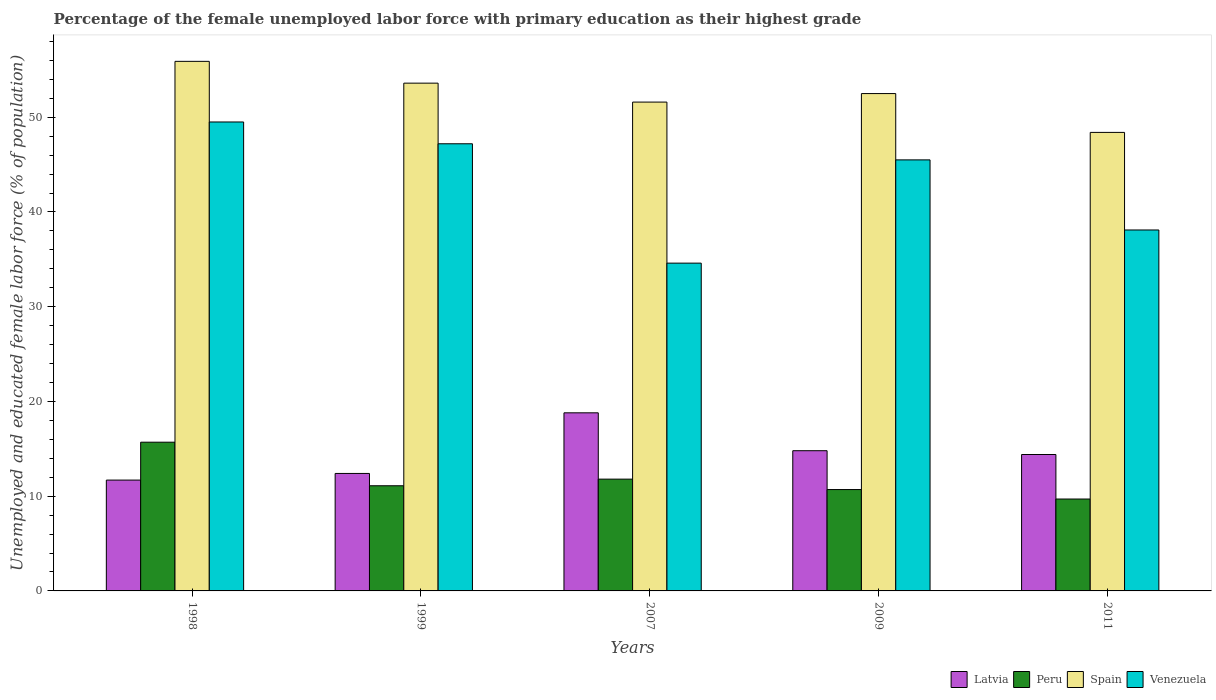How many different coloured bars are there?
Your response must be concise. 4. Are the number of bars per tick equal to the number of legend labels?
Provide a short and direct response. Yes. How many bars are there on the 2nd tick from the right?
Offer a very short reply. 4. What is the label of the 3rd group of bars from the left?
Ensure brevity in your answer.  2007. What is the percentage of the unemployed female labor force with primary education in Spain in 2007?
Make the answer very short. 51.6. Across all years, what is the maximum percentage of the unemployed female labor force with primary education in Latvia?
Make the answer very short. 18.8. Across all years, what is the minimum percentage of the unemployed female labor force with primary education in Peru?
Provide a short and direct response. 9.7. In which year was the percentage of the unemployed female labor force with primary education in Latvia minimum?
Make the answer very short. 1998. What is the total percentage of the unemployed female labor force with primary education in Venezuela in the graph?
Keep it short and to the point. 214.9. What is the difference between the percentage of the unemployed female labor force with primary education in Latvia in 1998 and that in 2007?
Provide a succinct answer. -7.1. What is the difference between the percentage of the unemployed female labor force with primary education in Venezuela in 2007 and the percentage of the unemployed female labor force with primary education in Latvia in 1998?
Your answer should be very brief. 22.9. What is the average percentage of the unemployed female labor force with primary education in Venezuela per year?
Keep it short and to the point. 42.98. In the year 2007, what is the difference between the percentage of the unemployed female labor force with primary education in Peru and percentage of the unemployed female labor force with primary education in Latvia?
Keep it short and to the point. -7. What is the ratio of the percentage of the unemployed female labor force with primary education in Venezuela in 1999 to that in 2011?
Your response must be concise. 1.24. Is the percentage of the unemployed female labor force with primary education in Venezuela in 2009 less than that in 2011?
Provide a short and direct response. No. What is the difference between the highest and the second highest percentage of the unemployed female labor force with primary education in Venezuela?
Provide a short and direct response. 2.3. What is the difference between the highest and the lowest percentage of the unemployed female labor force with primary education in Latvia?
Keep it short and to the point. 7.1. In how many years, is the percentage of the unemployed female labor force with primary education in Spain greater than the average percentage of the unemployed female labor force with primary education in Spain taken over all years?
Your answer should be compact. 3. Is the sum of the percentage of the unemployed female labor force with primary education in Latvia in 1998 and 2009 greater than the maximum percentage of the unemployed female labor force with primary education in Peru across all years?
Give a very brief answer. Yes. What does the 4th bar from the left in 2007 represents?
Offer a terse response. Venezuela. What does the 1st bar from the right in 2007 represents?
Ensure brevity in your answer.  Venezuela. Is it the case that in every year, the sum of the percentage of the unemployed female labor force with primary education in Spain and percentage of the unemployed female labor force with primary education in Latvia is greater than the percentage of the unemployed female labor force with primary education in Venezuela?
Make the answer very short. Yes. How many bars are there?
Provide a short and direct response. 20. How many years are there in the graph?
Keep it short and to the point. 5. What is the difference between two consecutive major ticks on the Y-axis?
Offer a very short reply. 10. Does the graph contain any zero values?
Offer a very short reply. No. Does the graph contain grids?
Ensure brevity in your answer.  No. Where does the legend appear in the graph?
Your response must be concise. Bottom right. How many legend labels are there?
Provide a succinct answer. 4. How are the legend labels stacked?
Keep it short and to the point. Horizontal. What is the title of the graph?
Keep it short and to the point. Percentage of the female unemployed labor force with primary education as their highest grade. What is the label or title of the X-axis?
Give a very brief answer. Years. What is the label or title of the Y-axis?
Your response must be concise. Unemployed and educated female labor force (% of population). What is the Unemployed and educated female labor force (% of population) in Latvia in 1998?
Your response must be concise. 11.7. What is the Unemployed and educated female labor force (% of population) in Peru in 1998?
Make the answer very short. 15.7. What is the Unemployed and educated female labor force (% of population) in Spain in 1998?
Ensure brevity in your answer.  55.9. What is the Unemployed and educated female labor force (% of population) in Venezuela in 1998?
Offer a terse response. 49.5. What is the Unemployed and educated female labor force (% of population) of Latvia in 1999?
Your answer should be very brief. 12.4. What is the Unemployed and educated female labor force (% of population) in Peru in 1999?
Keep it short and to the point. 11.1. What is the Unemployed and educated female labor force (% of population) in Spain in 1999?
Your response must be concise. 53.6. What is the Unemployed and educated female labor force (% of population) in Venezuela in 1999?
Provide a succinct answer. 47.2. What is the Unemployed and educated female labor force (% of population) in Latvia in 2007?
Keep it short and to the point. 18.8. What is the Unemployed and educated female labor force (% of population) in Peru in 2007?
Give a very brief answer. 11.8. What is the Unemployed and educated female labor force (% of population) of Spain in 2007?
Give a very brief answer. 51.6. What is the Unemployed and educated female labor force (% of population) of Venezuela in 2007?
Offer a terse response. 34.6. What is the Unemployed and educated female labor force (% of population) in Latvia in 2009?
Keep it short and to the point. 14.8. What is the Unemployed and educated female labor force (% of population) in Peru in 2009?
Provide a short and direct response. 10.7. What is the Unemployed and educated female labor force (% of population) of Spain in 2009?
Give a very brief answer. 52.5. What is the Unemployed and educated female labor force (% of population) in Venezuela in 2009?
Keep it short and to the point. 45.5. What is the Unemployed and educated female labor force (% of population) in Latvia in 2011?
Offer a terse response. 14.4. What is the Unemployed and educated female labor force (% of population) in Peru in 2011?
Your answer should be very brief. 9.7. What is the Unemployed and educated female labor force (% of population) of Spain in 2011?
Offer a terse response. 48.4. What is the Unemployed and educated female labor force (% of population) of Venezuela in 2011?
Provide a short and direct response. 38.1. Across all years, what is the maximum Unemployed and educated female labor force (% of population) of Latvia?
Offer a very short reply. 18.8. Across all years, what is the maximum Unemployed and educated female labor force (% of population) in Peru?
Provide a succinct answer. 15.7. Across all years, what is the maximum Unemployed and educated female labor force (% of population) of Spain?
Give a very brief answer. 55.9. Across all years, what is the maximum Unemployed and educated female labor force (% of population) in Venezuela?
Make the answer very short. 49.5. Across all years, what is the minimum Unemployed and educated female labor force (% of population) of Latvia?
Offer a very short reply. 11.7. Across all years, what is the minimum Unemployed and educated female labor force (% of population) of Peru?
Offer a very short reply. 9.7. Across all years, what is the minimum Unemployed and educated female labor force (% of population) in Spain?
Offer a very short reply. 48.4. Across all years, what is the minimum Unemployed and educated female labor force (% of population) in Venezuela?
Provide a short and direct response. 34.6. What is the total Unemployed and educated female labor force (% of population) of Latvia in the graph?
Provide a succinct answer. 72.1. What is the total Unemployed and educated female labor force (% of population) in Spain in the graph?
Your answer should be compact. 262. What is the total Unemployed and educated female labor force (% of population) of Venezuela in the graph?
Make the answer very short. 214.9. What is the difference between the Unemployed and educated female labor force (% of population) in Peru in 1998 and that in 1999?
Make the answer very short. 4.6. What is the difference between the Unemployed and educated female labor force (% of population) of Spain in 1998 and that in 1999?
Give a very brief answer. 2.3. What is the difference between the Unemployed and educated female labor force (% of population) of Peru in 1998 and that in 2007?
Ensure brevity in your answer.  3.9. What is the difference between the Unemployed and educated female labor force (% of population) in Spain in 1998 and that in 2007?
Your answer should be compact. 4.3. What is the difference between the Unemployed and educated female labor force (% of population) in Latvia in 1998 and that in 2009?
Your response must be concise. -3.1. What is the difference between the Unemployed and educated female labor force (% of population) of Spain in 1998 and that in 2009?
Your response must be concise. 3.4. What is the difference between the Unemployed and educated female labor force (% of population) in Venezuela in 1998 and that in 2009?
Make the answer very short. 4. What is the difference between the Unemployed and educated female labor force (% of population) in Peru in 1998 and that in 2011?
Your response must be concise. 6. What is the difference between the Unemployed and educated female labor force (% of population) of Latvia in 1999 and that in 2007?
Your response must be concise. -6.4. What is the difference between the Unemployed and educated female labor force (% of population) of Spain in 1999 and that in 2007?
Your answer should be compact. 2. What is the difference between the Unemployed and educated female labor force (% of population) of Peru in 1999 and that in 2009?
Give a very brief answer. 0.4. What is the difference between the Unemployed and educated female labor force (% of population) of Venezuela in 1999 and that in 2009?
Offer a very short reply. 1.7. What is the difference between the Unemployed and educated female labor force (% of population) in Spain in 1999 and that in 2011?
Your answer should be compact. 5.2. What is the difference between the Unemployed and educated female labor force (% of population) of Venezuela in 1999 and that in 2011?
Ensure brevity in your answer.  9.1. What is the difference between the Unemployed and educated female labor force (% of population) of Peru in 2007 and that in 2011?
Offer a very short reply. 2.1. What is the difference between the Unemployed and educated female labor force (% of population) in Spain in 2007 and that in 2011?
Offer a very short reply. 3.2. What is the difference between the Unemployed and educated female labor force (% of population) of Venezuela in 2007 and that in 2011?
Keep it short and to the point. -3.5. What is the difference between the Unemployed and educated female labor force (% of population) in Spain in 2009 and that in 2011?
Offer a very short reply. 4.1. What is the difference between the Unemployed and educated female labor force (% of population) of Venezuela in 2009 and that in 2011?
Ensure brevity in your answer.  7.4. What is the difference between the Unemployed and educated female labor force (% of population) in Latvia in 1998 and the Unemployed and educated female labor force (% of population) in Peru in 1999?
Your answer should be compact. 0.6. What is the difference between the Unemployed and educated female labor force (% of population) of Latvia in 1998 and the Unemployed and educated female labor force (% of population) of Spain in 1999?
Your answer should be very brief. -41.9. What is the difference between the Unemployed and educated female labor force (% of population) in Latvia in 1998 and the Unemployed and educated female labor force (% of population) in Venezuela in 1999?
Ensure brevity in your answer.  -35.5. What is the difference between the Unemployed and educated female labor force (% of population) of Peru in 1998 and the Unemployed and educated female labor force (% of population) of Spain in 1999?
Your answer should be very brief. -37.9. What is the difference between the Unemployed and educated female labor force (% of population) of Peru in 1998 and the Unemployed and educated female labor force (% of population) of Venezuela in 1999?
Offer a terse response. -31.5. What is the difference between the Unemployed and educated female labor force (% of population) in Spain in 1998 and the Unemployed and educated female labor force (% of population) in Venezuela in 1999?
Provide a succinct answer. 8.7. What is the difference between the Unemployed and educated female labor force (% of population) in Latvia in 1998 and the Unemployed and educated female labor force (% of population) in Peru in 2007?
Provide a short and direct response. -0.1. What is the difference between the Unemployed and educated female labor force (% of population) in Latvia in 1998 and the Unemployed and educated female labor force (% of population) in Spain in 2007?
Make the answer very short. -39.9. What is the difference between the Unemployed and educated female labor force (% of population) of Latvia in 1998 and the Unemployed and educated female labor force (% of population) of Venezuela in 2007?
Give a very brief answer. -22.9. What is the difference between the Unemployed and educated female labor force (% of population) of Peru in 1998 and the Unemployed and educated female labor force (% of population) of Spain in 2007?
Offer a terse response. -35.9. What is the difference between the Unemployed and educated female labor force (% of population) of Peru in 1998 and the Unemployed and educated female labor force (% of population) of Venezuela in 2007?
Provide a succinct answer. -18.9. What is the difference between the Unemployed and educated female labor force (% of population) in Spain in 1998 and the Unemployed and educated female labor force (% of population) in Venezuela in 2007?
Make the answer very short. 21.3. What is the difference between the Unemployed and educated female labor force (% of population) of Latvia in 1998 and the Unemployed and educated female labor force (% of population) of Peru in 2009?
Ensure brevity in your answer.  1. What is the difference between the Unemployed and educated female labor force (% of population) in Latvia in 1998 and the Unemployed and educated female labor force (% of population) in Spain in 2009?
Offer a terse response. -40.8. What is the difference between the Unemployed and educated female labor force (% of population) of Latvia in 1998 and the Unemployed and educated female labor force (% of population) of Venezuela in 2009?
Provide a short and direct response. -33.8. What is the difference between the Unemployed and educated female labor force (% of population) in Peru in 1998 and the Unemployed and educated female labor force (% of population) in Spain in 2009?
Give a very brief answer. -36.8. What is the difference between the Unemployed and educated female labor force (% of population) of Peru in 1998 and the Unemployed and educated female labor force (% of population) of Venezuela in 2009?
Provide a succinct answer. -29.8. What is the difference between the Unemployed and educated female labor force (% of population) in Spain in 1998 and the Unemployed and educated female labor force (% of population) in Venezuela in 2009?
Your answer should be compact. 10.4. What is the difference between the Unemployed and educated female labor force (% of population) of Latvia in 1998 and the Unemployed and educated female labor force (% of population) of Spain in 2011?
Your answer should be very brief. -36.7. What is the difference between the Unemployed and educated female labor force (% of population) in Latvia in 1998 and the Unemployed and educated female labor force (% of population) in Venezuela in 2011?
Offer a terse response. -26.4. What is the difference between the Unemployed and educated female labor force (% of population) in Peru in 1998 and the Unemployed and educated female labor force (% of population) in Spain in 2011?
Ensure brevity in your answer.  -32.7. What is the difference between the Unemployed and educated female labor force (% of population) of Peru in 1998 and the Unemployed and educated female labor force (% of population) of Venezuela in 2011?
Your answer should be very brief. -22.4. What is the difference between the Unemployed and educated female labor force (% of population) of Latvia in 1999 and the Unemployed and educated female labor force (% of population) of Spain in 2007?
Your answer should be very brief. -39.2. What is the difference between the Unemployed and educated female labor force (% of population) of Latvia in 1999 and the Unemployed and educated female labor force (% of population) of Venezuela in 2007?
Your answer should be compact. -22.2. What is the difference between the Unemployed and educated female labor force (% of population) in Peru in 1999 and the Unemployed and educated female labor force (% of population) in Spain in 2007?
Ensure brevity in your answer.  -40.5. What is the difference between the Unemployed and educated female labor force (% of population) in Peru in 1999 and the Unemployed and educated female labor force (% of population) in Venezuela in 2007?
Keep it short and to the point. -23.5. What is the difference between the Unemployed and educated female labor force (% of population) of Spain in 1999 and the Unemployed and educated female labor force (% of population) of Venezuela in 2007?
Offer a terse response. 19. What is the difference between the Unemployed and educated female labor force (% of population) of Latvia in 1999 and the Unemployed and educated female labor force (% of population) of Peru in 2009?
Ensure brevity in your answer.  1.7. What is the difference between the Unemployed and educated female labor force (% of population) in Latvia in 1999 and the Unemployed and educated female labor force (% of population) in Spain in 2009?
Offer a very short reply. -40.1. What is the difference between the Unemployed and educated female labor force (% of population) in Latvia in 1999 and the Unemployed and educated female labor force (% of population) in Venezuela in 2009?
Your answer should be very brief. -33.1. What is the difference between the Unemployed and educated female labor force (% of population) of Peru in 1999 and the Unemployed and educated female labor force (% of population) of Spain in 2009?
Offer a very short reply. -41.4. What is the difference between the Unemployed and educated female labor force (% of population) of Peru in 1999 and the Unemployed and educated female labor force (% of population) of Venezuela in 2009?
Provide a short and direct response. -34.4. What is the difference between the Unemployed and educated female labor force (% of population) of Spain in 1999 and the Unemployed and educated female labor force (% of population) of Venezuela in 2009?
Your response must be concise. 8.1. What is the difference between the Unemployed and educated female labor force (% of population) in Latvia in 1999 and the Unemployed and educated female labor force (% of population) in Peru in 2011?
Offer a terse response. 2.7. What is the difference between the Unemployed and educated female labor force (% of population) in Latvia in 1999 and the Unemployed and educated female labor force (% of population) in Spain in 2011?
Give a very brief answer. -36. What is the difference between the Unemployed and educated female labor force (% of population) in Latvia in 1999 and the Unemployed and educated female labor force (% of population) in Venezuela in 2011?
Offer a terse response. -25.7. What is the difference between the Unemployed and educated female labor force (% of population) of Peru in 1999 and the Unemployed and educated female labor force (% of population) of Spain in 2011?
Your response must be concise. -37.3. What is the difference between the Unemployed and educated female labor force (% of population) in Spain in 1999 and the Unemployed and educated female labor force (% of population) in Venezuela in 2011?
Make the answer very short. 15.5. What is the difference between the Unemployed and educated female labor force (% of population) in Latvia in 2007 and the Unemployed and educated female labor force (% of population) in Peru in 2009?
Provide a succinct answer. 8.1. What is the difference between the Unemployed and educated female labor force (% of population) of Latvia in 2007 and the Unemployed and educated female labor force (% of population) of Spain in 2009?
Provide a succinct answer. -33.7. What is the difference between the Unemployed and educated female labor force (% of population) of Latvia in 2007 and the Unemployed and educated female labor force (% of population) of Venezuela in 2009?
Make the answer very short. -26.7. What is the difference between the Unemployed and educated female labor force (% of population) in Peru in 2007 and the Unemployed and educated female labor force (% of population) in Spain in 2009?
Offer a very short reply. -40.7. What is the difference between the Unemployed and educated female labor force (% of population) in Peru in 2007 and the Unemployed and educated female labor force (% of population) in Venezuela in 2009?
Ensure brevity in your answer.  -33.7. What is the difference between the Unemployed and educated female labor force (% of population) of Latvia in 2007 and the Unemployed and educated female labor force (% of population) of Spain in 2011?
Your response must be concise. -29.6. What is the difference between the Unemployed and educated female labor force (% of population) of Latvia in 2007 and the Unemployed and educated female labor force (% of population) of Venezuela in 2011?
Your response must be concise. -19.3. What is the difference between the Unemployed and educated female labor force (% of population) of Peru in 2007 and the Unemployed and educated female labor force (% of population) of Spain in 2011?
Offer a terse response. -36.6. What is the difference between the Unemployed and educated female labor force (% of population) in Peru in 2007 and the Unemployed and educated female labor force (% of population) in Venezuela in 2011?
Keep it short and to the point. -26.3. What is the difference between the Unemployed and educated female labor force (% of population) of Latvia in 2009 and the Unemployed and educated female labor force (% of population) of Spain in 2011?
Give a very brief answer. -33.6. What is the difference between the Unemployed and educated female labor force (% of population) of Latvia in 2009 and the Unemployed and educated female labor force (% of population) of Venezuela in 2011?
Keep it short and to the point. -23.3. What is the difference between the Unemployed and educated female labor force (% of population) in Peru in 2009 and the Unemployed and educated female labor force (% of population) in Spain in 2011?
Make the answer very short. -37.7. What is the difference between the Unemployed and educated female labor force (% of population) in Peru in 2009 and the Unemployed and educated female labor force (% of population) in Venezuela in 2011?
Offer a very short reply. -27.4. What is the difference between the Unemployed and educated female labor force (% of population) of Spain in 2009 and the Unemployed and educated female labor force (% of population) of Venezuela in 2011?
Make the answer very short. 14.4. What is the average Unemployed and educated female labor force (% of population) in Latvia per year?
Your response must be concise. 14.42. What is the average Unemployed and educated female labor force (% of population) in Peru per year?
Your answer should be very brief. 11.8. What is the average Unemployed and educated female labor force (% of population) of Spain per year?
Give a very brief answer. 52.4. What is the average Unemployed and educated female labor force (% of population) of Venezuela per year?
Your answer should be compact. 42.98. In the year 1998, what is the difference between the Unemployed and educated female labor force (% of population) in Latvia and Unemployed and educated female labor force (% of population) in Spain?
Give a very brief answer. -44.2. In the year 1998, what is the difference between the Unemployed and educated female labor force (% of population) in Latvia and Unemployed and educated female labor force (% of population) in Venezuela?
Make the answer very short. -37.8. In the year 1998, what is the difference between the Unemployed and educated female labor force (% of population) of Peru and Unemployed and educated female labor force (% of population) of Spain?
Keep it short and to the point. -40.2. In the year 1998, what is the difference between the Unemployed and educated female labor force (% of population) of Peru and Unemployed and educated female labor force (% of population) of Venezuela?
Give a very brief answer. -33.8. In the year 1999, what is the difference between the Unemployed and educated female labor force (% of population) of Latvia and Unemployed and educated female labor force (% of population) of Spain?
Your response must be concise. -41.2. In the year 1999, what is the difference between the Unemployed and educated female labor force (% of population) of Latvia and Unemployed and educated female labor force (% of population) of Venezuela?
Give a very brief answer. -34.8. In the year 1999, what is the difference between the Unemployed and educated female labor force (% of population) of Peru and Unemployed and educated female labor force (% of population) of Spain?
Your answer should be compact. -42.5. In the year 1999, what is the difference between the Unemployed and educated female labor force (% of population) in Peru and Unemployed and educated female labor force (% of population) in Venezuela?
Make the answer very short. -36.1. In the year 1999, what is the difference between the Unemployed and educated female labor force (% of population) of Spain and Unemployed and educated female labor force (% of population) of Venezuela?
Provide a short and direct response. 6.4. In the year 2007, what is the difference between the Unemployed and educated female labor force (% of population) of Latvia and Unemployed and educated female labor force (% of population) of Peru?
Make the answer very short. 7. In the year 2007, what is the difference between the Unemployed and educated female labor force (% of population) of Latvia and Unemployed and educated female labor force (% of population) of Spain?
Your answer should be very brief. -32.8. In the year 2007, what is the difference between the Unemployed and educated female labor force (% of population) in Latvia and Unemployed and educated female labor force (% of population) in Venezuela?
Your answer should be very brief. -15.8. In the year 2007, what is the difference between the Unemployed and educated female labor force (% of population) of Peru and Unemployed and educated female labor force (% of population) of Spain?
Ensure brevity in your answer.  -39.8. In the year 2007, what is the difference between the Unemployed and educated female labor force (% of population) of Peru and Unemployed and educated female labor force (% of population) of Venezuela?
Provide a succinct answer. -22.8. In the year 2009, what is the difference between the Unemployed and educated female labor force (% of population) of Latvia and Unemployed and educated female labor force (% of population) of Spain?
Give a very brief answer. -37.7. In the year 2009, what is the difference between the Unemployed and educated female labor force (% of population) of Latvia and Unemployed and educated female labor force (% of population) of Venezuela?
Your answer should be compact. -30.7. In the year 2009, what is the difference between the Unemployed and educated female labor force (% of population) in Peru and Unemployed and educated female labor force (% of population) in Spain?
Keep it short and to the point. -41.8. In the year 2009, what is the difference between the Unemployed and educated female labor force (% of population) of Peru and Unemployed and educated female labor force (% of population) of Venezuela?
Give a very brief answer. -34.8. In the year 2009, what is the difference between the Unemployed and educated female labor force (% of population) of Spain and Unemployed and educated female labor force (% of population) of Venezuela?
Ensure brevity in your answer.  7. In the year 2011, what is the difference between the Unemployed and educated female labor force (% of population) in Latvia and Unemployed and educated female labor force (% of population) in Peru?
Your answer should be very brief. 4.7. In the year 2011, what is the difference between the Unemployed and educated female labor force (% of population) in Latvia and Unemployed and educated female labor force (% of population) in Spain?
Offer a terse response. -34. In the year 2011, what is the difference between the Unemployed and educated female labor force (% of population) in Latvia and Unemployed and educated female labor force (% of population) in Venezuela?
Offer a terse response. -23.7. In the year 2011, what is the difference between the Unemployed and educated female labor force (% of population) in Peru and Unemployed and educated female labor force (% of population) in Spain?
Make the answer very short. -38.7. In the year 2011, what is the difference between the Unemployed and educated female labor force (% of population) of Peru and Unemployed and educated female labor force (% of population) of Venezuela?
Ensure brevity in your answer.  -28.4. In the year 2011, what is the difference between the Unemployed and educated female labor force (% of population) of Spain and Unemployed and educated female labor force (% of population) of Venezuela?
Ensure brevity in your answer.  10.3. What is the ratio of the Unemployed and educated female labor force (% of population) of Latvia in 1998 to that in 1999?
Offer a terse response. 0.94. What is the ratio of the Unemployed and educated female labor force (% of population) of Peru in 1998 to that in 1999?
Offer a terse response. 1.41. What is the ratio of the Unemployed and educated female labor force (% of population) in Spain in 1998 to that in 1999?
Your answer should be compact. 1.04. What is the ratio of the Unemployed and educated female labor force (% of population) in Venezuela in 1998 to that in 1999?
Offer a terse response. 1.05. What is the ratio of the Unemployed and educated female labor force (% of population) of Latvia in 1998 to that in 2007?
Ensure brevity in your answer.  0.62. What is the ratio of the Unemployed and educated female labor force (% of population) in Peru in 1998 to that in 2007?
Provide a short and direct response. 1.33. What is the ratio of the Unemployed and educated female labor force (% of population) in Venezuela in 1998 to that in 2007?
Offer a terse response. 1.43. What is the ratio of the Unemployed and educated female labor force (% of population) of Latvia in 1998 to that in 2009?
Keep it short and to the point. 0.79. What is the ratio of the Unemployed and educated female labor force (% of population) in Peru in 1998 to that in 2009?
Your answer should be compact. 1.47. What is the ratio of the Unemployed and educated female labor force (% of population) of Spain in 1998 to that in 2009?
Your response must be concise. 1.06. What is the ratio of the Unemployed and educated female labor force (% of population) of Venezuela in 1998 to that in 2009?
Your answer should be very brief. 1.09. What is the ratio of the Unemployed and educated female labor force (% of population) in Latvia in 1998 to that in 2011?
Your answer should be compact. 0.81. What is the ratio of the Unemployed and educated female labor force (% of population) in Peru in 1998 to that in 2011?
Give a very brief answer. 1.62. What is the ratio of the Unemployed and educated female labor force (% of population) of Spain in 1998 to that in 2011?
Provide a short and direct response. 1.16. What is the ratio of the Unemployed and educated female labor force (% of population) of Venezuela in 1998 to that in 2011?
Make the answer very short. 1.3. What is the ratio of the Unemployed and educated female labor force (% of population) in Latvia in 1999 to that in 2007?
Make the answer very short. 0.66. What is the ratio of the Unemployed and educated female labor force (% of population) in Peru in 1999 to that in 2007?
Provide a short and direct response. 0.94. What is the ratio of the Unemployed and educated female labor force (% of population) of Spain in 1999 to that in 2007?
Provide a succinct answer. 1.04. What is the ratio of the Unemployed and educated female labor force (% of population) of Venezuela in 1999 to that in 2007?
Your answer should be very brief. 1.36. What is the ratio of the Unemployed and educated female labor force (% of population) of Latvia in 1999 to that in 2009?
Keep it short and to the point. 0.84. What is the ratio of the Unemployed and educated female labor force (% of population) in Peru in 1999 to that in 2009?
Offer a terse response. 1.04. What is the ratio of the Unemployed and educated female labor force (% of population) in Venezuela in 1999 to that in 2009?
Provide a short and direct response. 1.04. What is the ratio of the Unemployed and educated female labor force (% of population) in Latvia in 1999 to that in 2011?
Your response must be concise. 0.86. What is the ratio of the Unemployed and educated female labor force (% of population) of Peru in 1999 to that in 2011?
Provide a succinct answer. 1.14. What is the ratio of the Unemployed and educated female labor force (% of population) in Spain in 1999 to that in 2011?
Your answer should be very brief. 1.11. What is the ratio of the Unemployed and educated female labor force (% of population) of Venezuela in 1999 to that in 2011?
Ensure brevity in your answer.  1.24. What is the ratio of the Unemployed and educated female labor force (% of population) of Latvia in 2007 to that in 2009?
Offer a very short reply. 1.27. What is the ratio of the Unemployed and educated female labor force (% of population) in Peru in 2007 to that in 2009?
Provide a succinct answer. 1.1. What is the ratio of the Unemployed and educated female labor force (% of population) of Spain in 2007 to that in 2009?
Give a very brief answer. 0.98. What is the ratio of the Unemployed and educated female labor force (% of population) in Venezuela in 2007 to that in 2009?
Make the answer very short. 0.76. What is the ratio of the Unemployed and educated female labor force (% of population) of Latvia in 2007 to that in 2011?
Your answer should be compact. 1.31. What is the ratio of the Unemployed and educated female labor force (% of population) in Peru in 2007 to that in 2011?
Your answer should be very brief. 1.22. What is the ratio of the Unemployed and educated female labor force (% of population) in Spain in 2007 to that in 2011?
Offer a very short reply. 1.07. What is the ratio of the Unemployed and educated female labor force (% of population) in Venezuela in 2007 to that in 2011?
Give a very brief answer. 0.91. What is the ratio of the Unemployed and educated female labor force (% of population) in Latvia in 2009 to that in 2011?
Offer a very short reply. 1.03. What is the ratio of the Unemployed and educated female labor force (% of population) of Peru in 2009 to that in 2011?
Keep it short and to the point. 1.1. What is the ratio of the Unemployed and educated female labor force (% of population) in Spain in 2009 to that in 2011?
Offer a terse response. 1.08. What is the ratio of the Unemployed and educated female labor force (% of population) of Venezuela in 2009 to that in 2011?
Provide a short and direct response. 1.19. What is the difference between the highest and the second highest Unemployed and educated female labor force (% of population) in Spain?
Your answer should be very brief. 2.3. What is the difference between the highest and the lowest Unemployed and educated female labor force (% of population) in Latvia?
Offer a very short reply. 7.1. What is the difference between the highest and the lowest Unemployed and educated female labor force (% of population) in Peru?
Give a very brief answer. 6. What is the difference between the highest and the lowest Unemployed and educated female labor force (% of population) in Venezuela?
Your answer should be very brief. 14.9. 